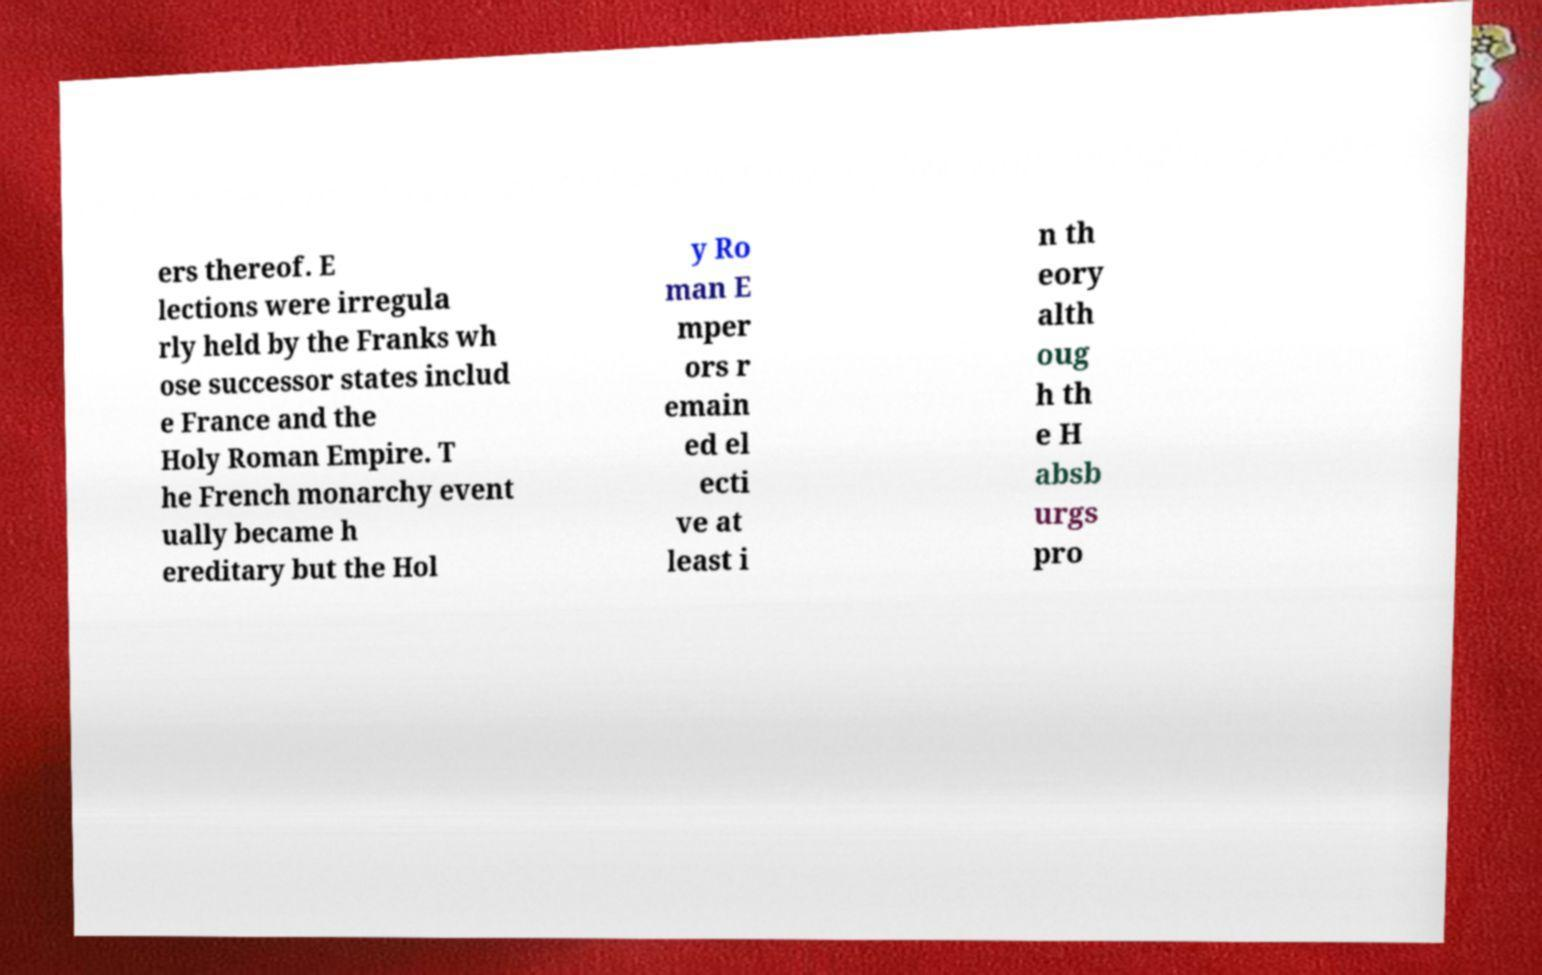Can you read and provide the text displayed in the image?This photo seems to have some interesting text. Can you extract and type it out for me? ers thereof. E lections were irregula rly held by the Franks wh ose successor states includ e France and the Holy Roman Empire. T he French monarchy event ually became h ereditary but the Hol y Ro man E mper ors r emain ed el ecti ve at least i n th eory alth oug h th e H absb urgs pro 